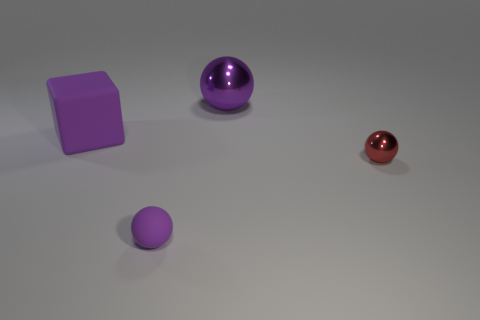There is a metal ball in front of the purple matte cube; is there a cube that is behind it?
Your response must be concise. Yes. Are there fewer small purple metal balls than red spheres?
Ensure brevity in your answer.  Yes. What number of large shiny things are the same shape as the small matte object?
Keep it short and to the point. 1. What number of purple things are tiny cylinders or metal things?
Your answer should be compact. 1. There is a purple rubber object that is in front of the small ball right of the tiny purple rubber ball; what is its size?
Your response must be concise. Small. There is a small purple object that is the same shape as the large purple metallic object; what material is it?
Give a very brief answer. Rubber. What number of other cubes are the same size as the purple cube?
Offer a very short reply. 0. Is the size of the purple shiny thing the same as the purple matte block?
Ensure brevity in your answer.  Yes. There is a purple thing that is behind the small metallic sphere and on the left side of the large purple metal object; what is its size?
Make the answer very short. Large. Is the number of big purple metal things that are behind the tiny purple rubber object greater than the number of matte blocks on the right side of the large purple shiny object?
Provide a short and direct response. Yes. 